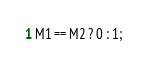Convert code to text. <code><loc_0><loc_0><loc_500><loc_500><_C#_>M1 == M2 ? 0 : 1;</code> 